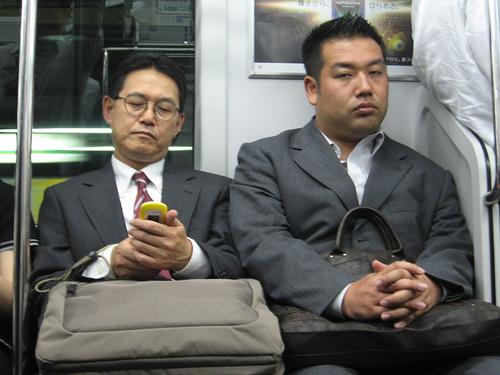Does the guy on the right look happy?
Answer briefly. No. What color is the man's cell phone?
Give a very brief answer. Yellow. What are the men wearing?
Keep it brief. Suits. 